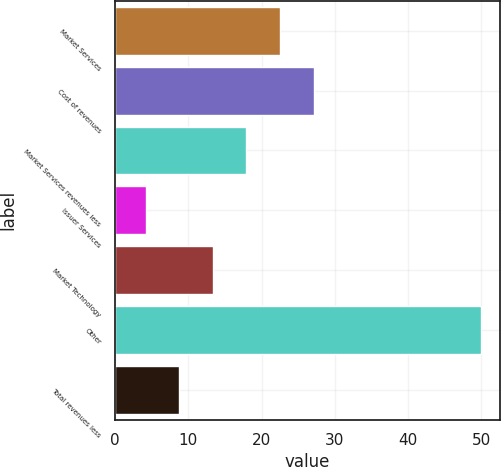Convert chart. <chart><loc_0><loc_0><loc_500><loc_500><bar_chart><fcel>Market Services<fcel>Cost of revenues<fcel>Market Services revenues less<fcel>Issuer Services<fcel>Market Technology<fcel>Other<fcel>Total revenues less<nl><fcel>22.52<fcel>27.1<fcel>17.94<fcel>4.2<fcel>13.36<fcel>50<fcel>8.78<nl></chart> 